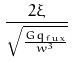Convert formula to latex. <formula><loc_0><loc_0><loc_500><loc_500>\frac { 2 \xi } { \sqrt { \frac { G q _ { f u x } } { w ^ { 3 } } } }</formula> 